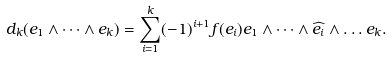<formula> <loc_0><loc_0><loc_500><loc_500>d _ { k } ( e _ { 1 } \wedge \dots \wedge e _ { k } ) = \sum ^ { k } _ { i = 1 } ( - 1 ) ^ { i + 1 } f ( e _ { i } ) e _ { 1 } \wedge \dots \wedge \widehat { e _ { i } } \wedge \dots e _ { k } .</formula> 